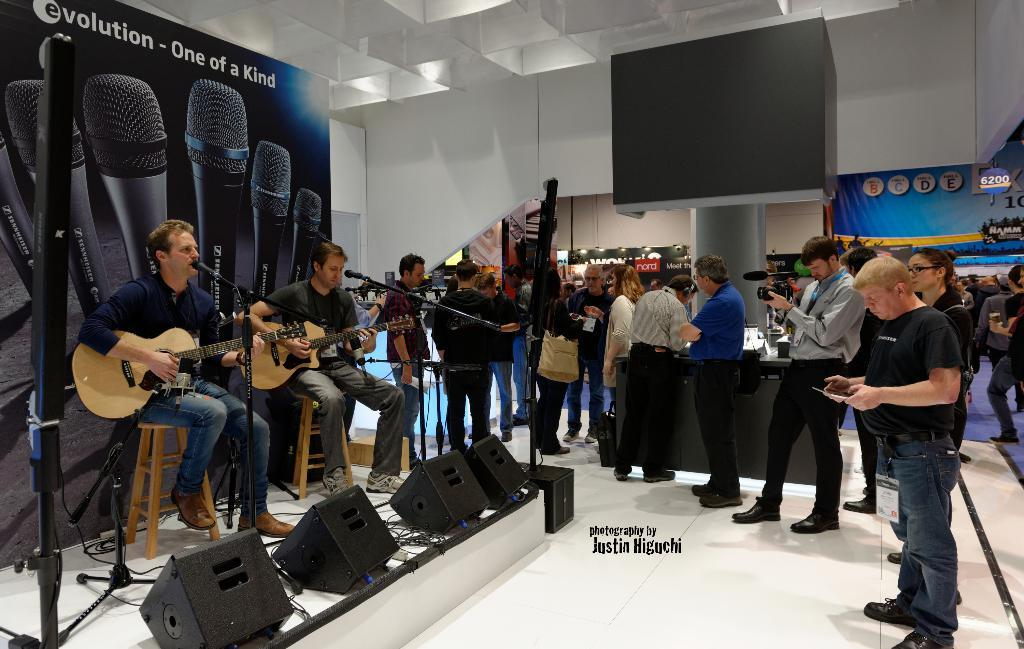What are the two men doing in the image? The two men are playing guitar. What is in front of the men? There is a microphone in front of the men. Who else is present in the image? There are people gathered around them. Where is the event taking place? The event is taking place in a shopping mall. What type of face can be seen on the van parked near the event? There is no van present in the image, so it is not possible to answer that question. 